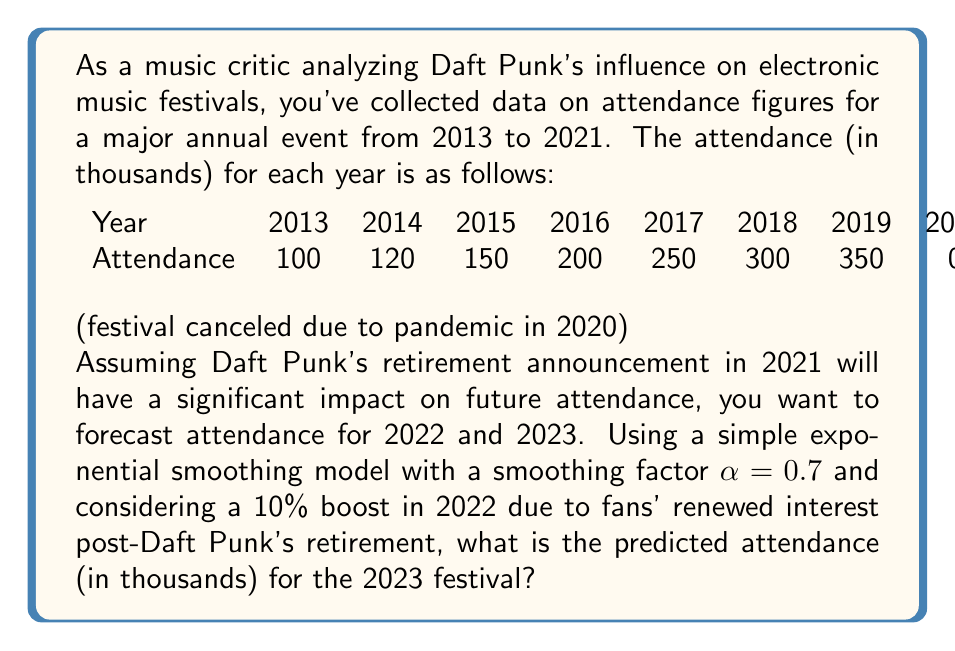Provide a solution to this math problem. To solve this problem, we'll use the following steps:

1. Apply simple exponential smoothing to the given data.
2. Calculate the forecast for 2022, including the 10% boost.
3. Use the 2022 forecast to predict 2023 attendance.

Step 1: Simple Exponential Smoothing

The formula for simple exponential smoothing is:

$$F_{t+1} = \alpha Y_t + (1-\alpha)F_t$$

Where:
$F_{t+1}$ is the forecast for the next period
$\alpha$ is the smoothing factor (0.7 in this case)
$Y_t$ is the actual value for the current period
$F_t$ is the forecast for the current period

We'll start with 2013 as our initial forecast. Then for each subsequent year:

2014: $F_{2014} = 0.7(100) + 0.3(100) = 100$
2015: $F_{2015} = 0.7(120) + 0.3(100) = 114$
2016: $F_{2016} = 0.7(150) + 0.3(114) = 139.2$
2017: $F_{2017} = 0.7(200) + 0.3(139.2) = 181.76$
2018: $F_{2018} = 0.7(250) + 0.3(181.76) = 229.528$
2019: $F_{2019} = 0.7(300) + 0.3(229.528) = 278.8584$
2020: $F_{2020} = 0.7(350) + 0.3(278.8584) = 328.65752$
2021: $F_{2021} = 0.7(0) + 0.3(328.65752) = 98.597256$

Step 2: Forecast for 2022

2022: $F_{2022} = 0.7(400) + 0.3(98.597256) = 309.579177$

Now, we apply the 10% boost due to Daft Punk's retirement:

$F_{2022\text{ (boosted)}} = 309.579177 \times 1.1 = 340.5370947$

Step 3: Forecast for 2023

Using the boosted 2022 forecast as our new actual value:

$F_{2023} = 0.7(340.5370947) + 0.3(340.5370947) = 340.5370947$

Therefore, the predicted attendance for the 2023 festival is approximately 340,537 people.
Answer: 340.54 thousand (rounded to 2 decimal places) 